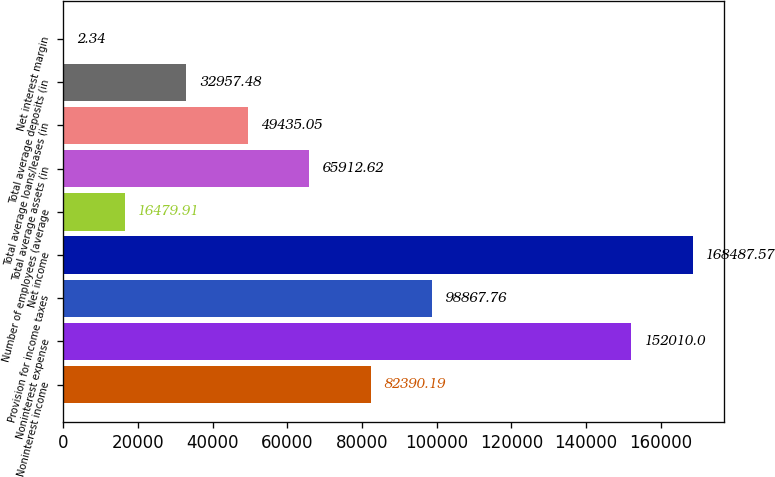Convert chart to OTSL. <chart><loc_0><loc_0><loc_500><loc_500><bar_chart><fcel>Noninterest income<fcel>Noninterest expense<fcel>Provision for income taxes<fcel>Net income<fcel>Number of employees (average<fcel>Total average assets (in<fcel>Total average loans/leases (in<fcel>Total average deposits (in<fcel>Net interest margin<nl><fcel>82390.2<fcel>152010<fcel>98867.8<fcel>168488<fcel>16479.9<fcel>65912.6<fcel>49435.1<fcel>32957.5<fcel>2.34<nl></chart> 